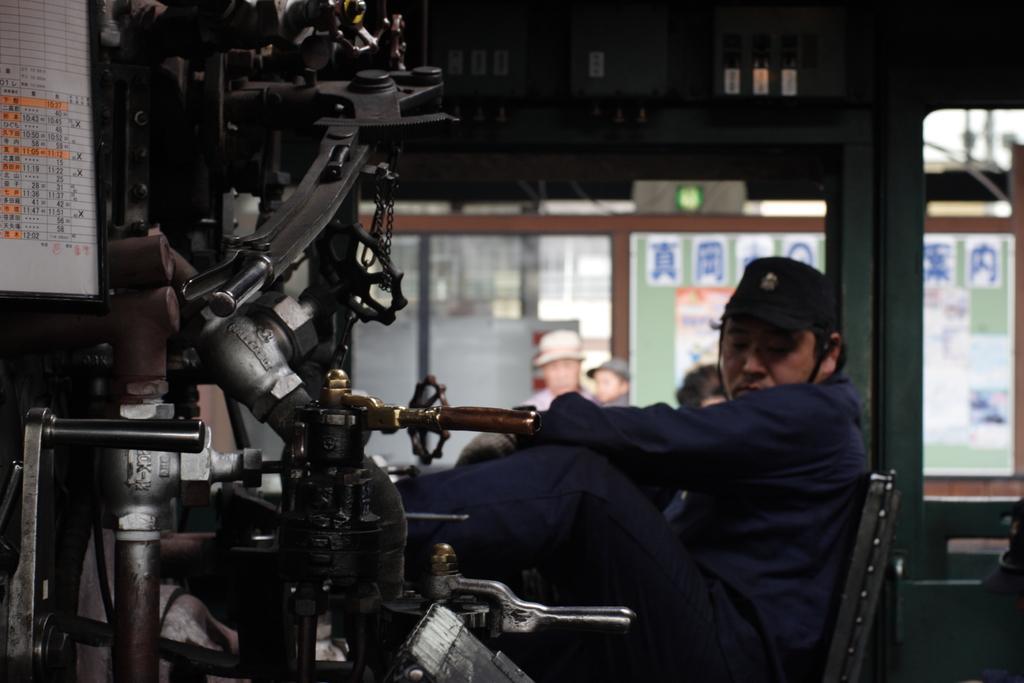In one or two sentences, can you explain what this image depicts? In this image there is one person sitting at right side of this image. There is some machinery at left side of this image. There is one paper calendar at top left side of this image and there is a wall in the background. there are some windows in middle of this image. 